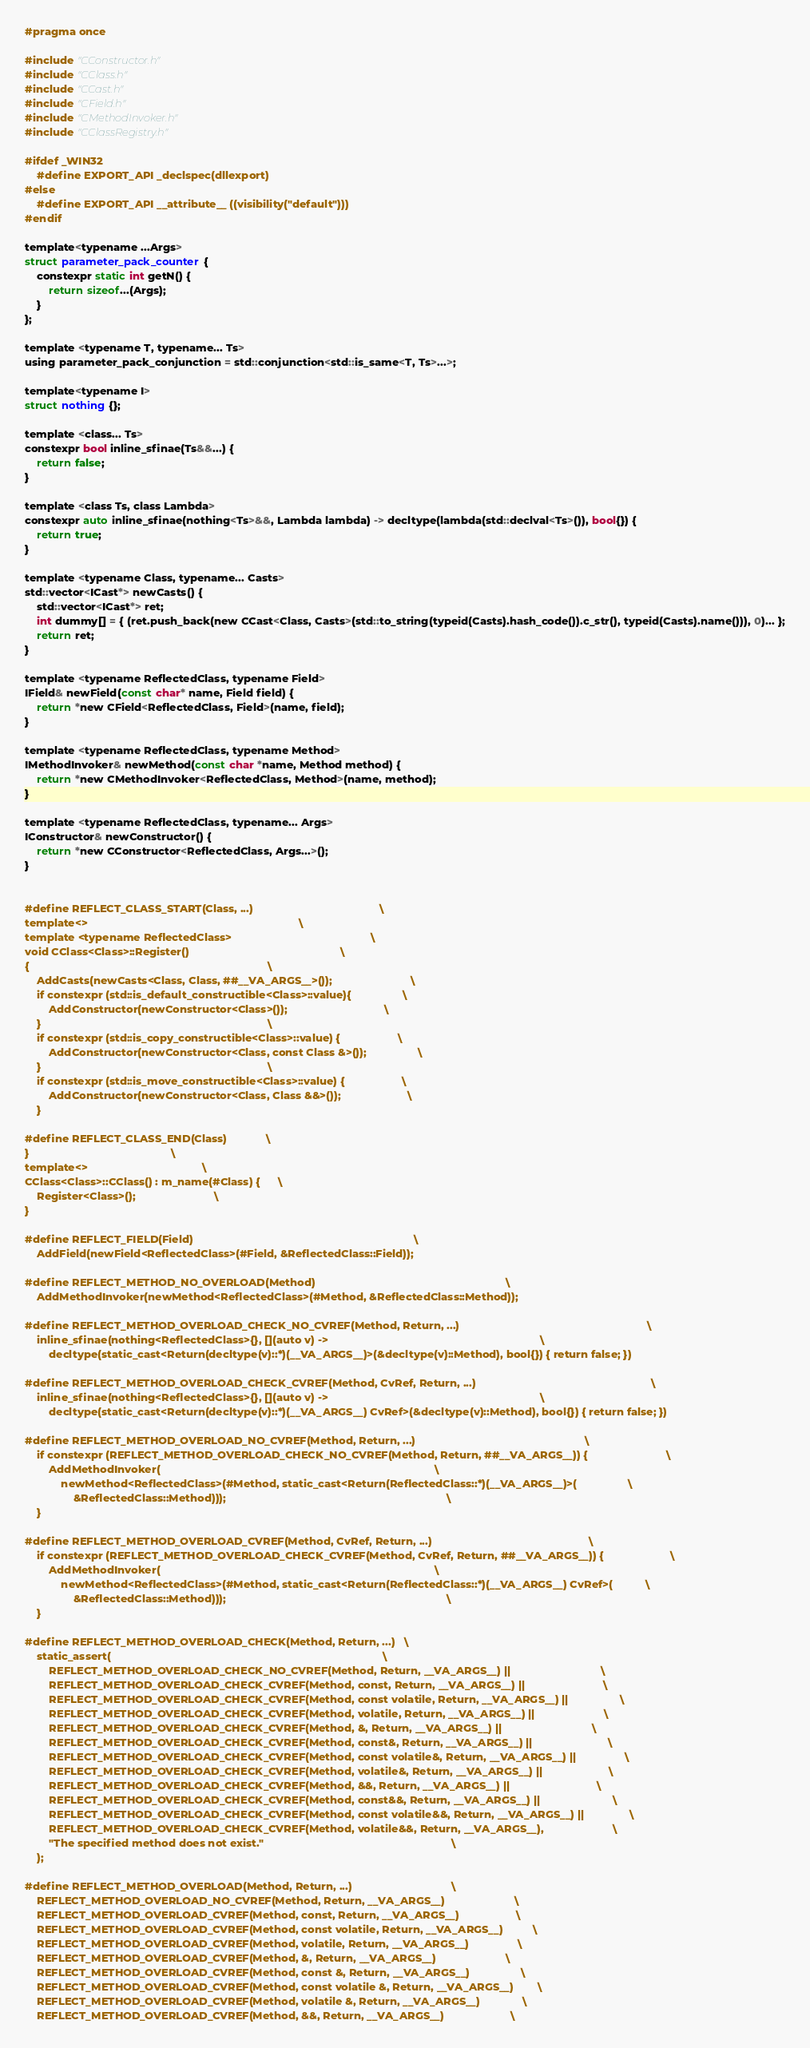<code> <loc_0><loc_0><loc_500><loc_500><_C_>#pragma once

#include "CConstructor.h"
#include "CClass.h"
#include "CCast.h"
#include "CField.h"
#include "CMethodInvoker.h"
#include "CClassRegistry.h"

#ifdef _WIN32
    #define EXPORT_API _declspec(dllexport)
#else
    #define EXPORT_API __attribute__ ((visibility("default")))
#endif

template<typename ...Args>
struct parameter_pack_counter {
	constexpr static int getN() {
		return sizeof...(Args);
	}
};

template <typename T, typename... Ts>
using parameter_pack_conjunction = std::conjunction<std::is_same<T, Ts>...>;

template<typename I>
struct nothing {};

template <class... Ts>
constexpr bool inline_sfinae(Ts&&...) {
	return false;
}

template <class Ts, class Lambda>
constexpr auto inline_sfinae(nothing<Ts>&&, Lambda lambda) -> decltype(lambda(std::declval<Ts>()), bool{}) {
	return true;
}

template <typename Class, typename... Casts>
std::vector<ICast*> newCasts() {
	std::vector<ICast*> ret;
	int dummy[] = { (ret.push_back(new CCast<Class, Casts>(std::to_string(typeid(Casts).hash_code()).c_str(), typeid(Casts).name())), 0)... };
	return ret;
}

template <typename ReflectedClass, typename Field>
IField& newField(const char* name, Field field) {
	return *new CField<ReflectedClass, Field>(name, field);
}

template <typename ReflectedClass, typename Method>
IMethodInvoker& newMethod(const char *name, Method method) {
	return *new CMethodInvoker<ReflectedClass, Method>(name, method);
}

template <typename ReflectedClass, typename... Args>
IConstructor& newConstructor() {
	return *new CConstructor<ReflectedClass, Args...>();
}


#define REFLECT_CLASS_START(Class, ...)											\
template<>																		\
template <typename ReflectedClass>												\
void CClass<Class>::Register()													\
{																				\
	AddCasts(newCasts<Class, Class, ##__VA_ARGS__>());							\
	if constexpr (std::is_default_constructible<Class>::value){					\
		AddConstructor(newConstructor<Class>());								\
	}																			\
	if constexpr (std::is_copy_constructible<Class>::value) {					\
		AddConstructor(newConstructor<Class, const Class &>());					\
	}																			\
	if constexpr (std::is_move_constructible<Class>::value) {					\
		AddConstructor(newConstructor<Class, Class &&>());						\
	}

#define REFLECT_CLASS_END(Class)				\
}												\
template<>										\
CClass<Class>::CClass() : m_name(#Class) {		\
	Register<Class>();							\
}	

#define REFLECT_FIELD(Field)																			\
	AddField(newField<ReflectedClass>(#Field, &ReflectedClass::Field));

#define REFLECT_METHOD_NO_OVERLOAD(Method)																\
	AddMethodInvoker(newMethod<ReflectedClass>(#Method, &ReflectedClass::Method));

#define REFLECT_METHOD_OVERLOAD_CHECK_NO_CVREF(Method, Return, ...)																\
	inline_sfinae(nothing<ReflectedClass>{}, [](auto v) ->																		\
		decltype(static_cast<Return(decltype(v)::*)(__VA_ARGS__)>(&decltype(v)::Method), bool{}) { return false; })

#define REFLECT_METHOD_OVERLOAD_CHECK_CVREF(Method, CvRef, Return, ...)															\
	inline_sfinae(nothing<ReflectedClass>{}, [](auto v) ->																		\
		decltype(static_cast<Return(decltype(v)::*)(__VA_ARGS__) CvRef>(&decltype(v)::Method), bool{}) { return false; })

#define REFLECT_METHOD_OVERLOAD_NO_CVREF(Method, Return, ...)														\
	if constexpr (REFLECT_METHOD_OVERLOAD_CHECK_NO_CVREF(Method, Return, ##__VA_ARGS__)) {							\
		AddMethodInvoker(																							\
			newMethod<ReflectedClass>(#Method, static_cast<Return(ReflectedClass::*)(__VA_ARGS__)>(					\
				&ReflectedClass::Method)));																			\
	}

#define REFLECT_METHOD_OVERLOAD_CVREF(Method, CvRef, Return, ...)													\
	if constexpr (REFLECT_METHOD_OVERLOAD_CHECK_CVREF(Method, CvRef, Return, ##__VA_ARGS__)) {						\
		AddMethodInvoker(																							\
			newMethod<ReflectedClass>(#Method, static_cast<Return(ReflectedClass::*)(__VA_ARGS__) CvRef>(			\
				&ReflectedClass::Method)));																			\
	}

#define REFLECT_METHOD_OVERLOAD_CHECK(Method, Return, ...)	\
	static_assert(																							\
		REFLECT_METHOD_OVERLOAD_CHECK_NO_CVREF(Method, Return, __VA_ARGS__) ||								\
		REFLECT_METHOD_OVERLOAD_CHECK_CVREF(Method, const, Return, __VA_ARGS__) ||							\
		REFLECT_METHOD_OVERLOAD_CHECK_CVREF(Method, const volatile, Return, __VA_ARGS__) ||					\
		REFLECT_METHOD_OVERLOAD_CHECK_CVREF(Method, volatile, Return, __VA_ARGS__) ||						\
		REFLECT_METHOD_OVERLOAD_CHECK_CVREF(Method, &, Return, __VA_ARGS__) ||								\
		REFLECT_METHOD_OVERLOAD_CHECK_CVREF(Method, const&, Return, __VA_ARGS__) ||							\
		REFLECT_METHOD_OVERLOAD_CHECK_CVREF(Method, const volatile&, Return, __VA_ARGS__) ||				\
		REFLECT_METHOD_OVERLOAD_CHECK_CVREF(Method, volatile&, Return, __VA_ARGS__) ||						\
		REFLECT_METHOD_OVERLOAD_CHECK_CVREF(Method, &&, Return, __VA_ARGS__) ||								\
		REFLECT_METHOD_OVERLOAD_CHECK_CVREF(Method, const&&, Return, __VA_ARGS__) ||						\
		REFLECT_METHOD_OVERLOAD_CHECK_CVREF(Method, const volatile&&, Return, __VA_ARGS__) ||				\
		REFLECT_METHOD_OVERLOAD_CHECK_CVREF(Method, volatile&&, Return, __VA_ARGS__),						\
		"The specified method does not exist."																\
	);

#define REFLECT_METHOD_OVERLOAD(Method, Return, ...)									\
	REFLECT_METHOD_OVERLOAD_NO_CVREF(Method, Return, __VA_ARGS__)						\
	REFLECT_METHOD_OVERLOAD_CVREF(Method, const, Return, __VA_ARGS__)					\
	REFLECT_METHOD_OVERLOAD_CVREF(Method, const volatile, Return, __VA_ARGS__)			\
	REFLECT_METHOD_OVERLOAD_CVREF(Method, volatile, Return, __VA_ARGS__)				\
	REFLECT_METHOD_OVERLOAD_CVREF(Method, &, Return, __VA_ARGS__)						\
	REFLECT_METHOD_OVERLOAD_CVREF(Method, const &, Return, __VA_ARGS__)					\
	REFLECT_METHOD_OVERLOAD_CVREF(Method, const volatile &, Return, __VA_ARGS__)		\
	REFLECT_METHOD_OVERLOAD_CVREF(Method, volatile &, Return, __VA_ARGS__)				\
	REFLECT_METHOD_OVERLOAD_CVREF(Method, &&, Return, __VA_ARGS__)						\</code> 